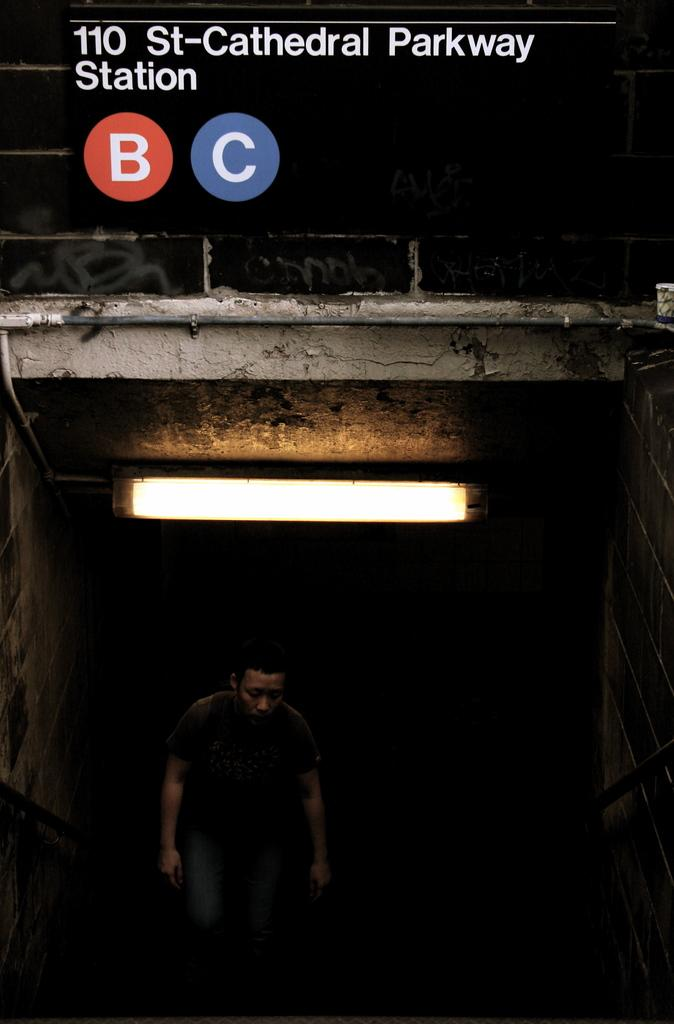What is the main subject of the image? There is a person in the image. Are there any words or letters in the image? Yes, there is some text in the image. What can be observed about the background of the image? The background of the image is dark. What type of juice is being served in the yard in the image? There is no juice or yard present in the image; it only features a person and some text against a dark background. 